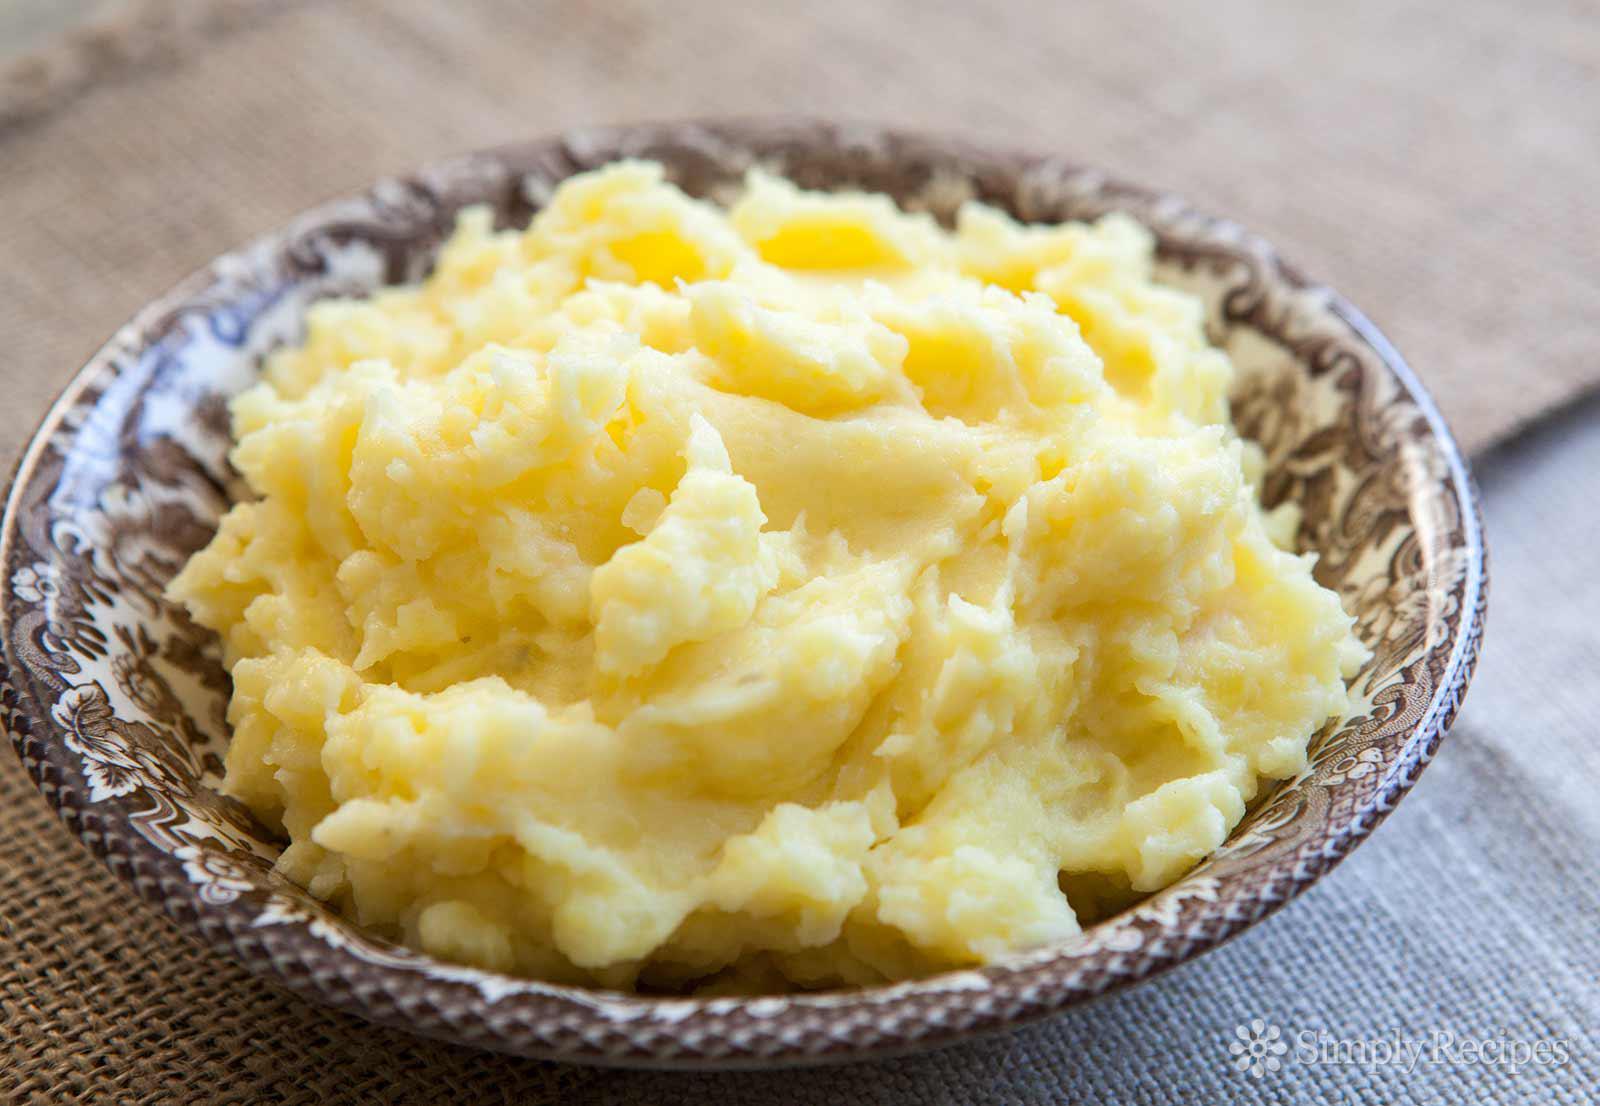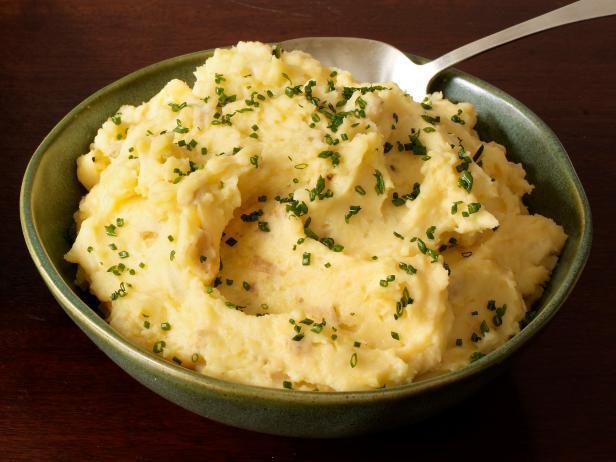The first image is the image on the left, the second image is the image on the right. Analyze the images presented: Is the assertion "There is one spoon shown." valid? Answer yes or no. Yes. The first image is the image on the left, the second image is the image on the right. Assess this claim about the two images: "The mashed potato bowl on the right contains a serving utensil.". Correct or not? Answer yes or no. Yes. 